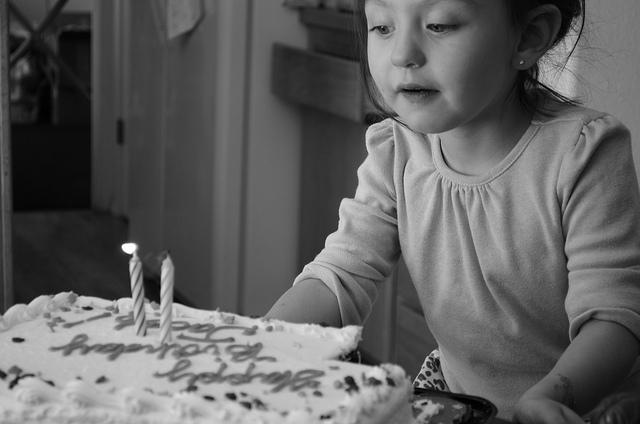What is the type of cake?
Answer briefly. Birthday. Has the cake been cut?
Quick response, please. Yes. Are they celebrating a child's 1st birthday?
Give a very brief answer. No. How many candles are on the cake?
Concise answer only. 2. How many layers does the cake have?
Write a very short answer. 1. How many layers are in the cake?
Concise answer only. 1. Does the little girl look happy?
Quick response, please. Yes. How many slices is she cutting?
Quick response, please. 1. How many candles on the cake?
Keep it brief. 2. Is her hair a natural color?
Keep it brief. Yes. How many different desserts are there?
Answer briefly. 1. Is the child's face clean?
Write a very short answer. Yes. Where is this woman?
Write a very short answer. Kitchen. What is the kid having his mouth open for?
Short answer required. Blowing. Is this a meal time photograph?
Be succinct. Yes. How much dessert is left?
Give a very brief answer. Most of it. Did the baby touch the cake?
Give a very brief answer. No. How many candles are on the food?
Keep it brief. 2. What color is the letter icing on top of the cake?
Keep it brief. Gray. What is the food sitting on?
Be succinct. Table. What does the child appear to be doing?
Quick response, please. Blowing out candles. What is the girl eating?
Be succinct. Cake. How old is this little girl?
Answer briefly. 2. Did the girl blow out both candles?
Short answer required. No. Is this a restaurant?
Short answer required. No. Is she wearing glasses?
Concise answer only. No. How old is the person this cake is for?
Be succinct. 2. 